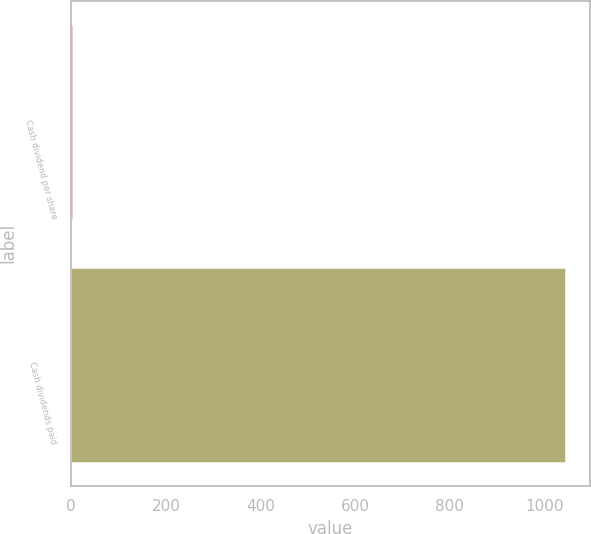Convert chart. <chart><loc_0><loc_0><loc_500><loc_500><bar_chart><fcel>Cash dividend per share<fcel>Cash dividends paid<nl><fcel>1<fcel>1044<nl></chart> 